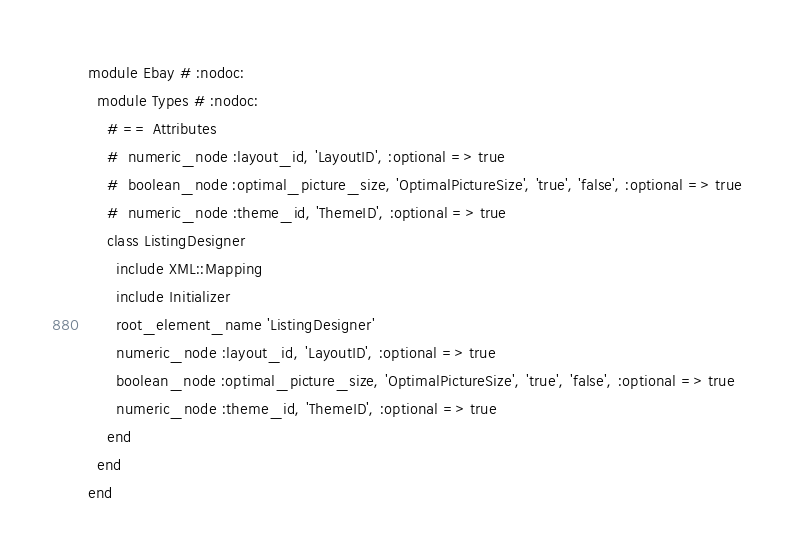<code> <loc_0><loc_0><loc_500><loc_500><_Ruby_>
module Ebay # :nodoc:
  module Types # :nodoc:
    # == Attributes
    #  numeric_node :layout_id, 'LayoutID', :optional => true
    #  boolean_node :optimal_picture_size, 'OptimalPictureSize', 'true', 'false', :optional => true
    #  numeric_node :theme_id, 'ThemeID', :optional => true
    class ListingDesigner
      include XML::Mapping
      include Initializer
      root_element_name 'ListingDesigner'
      numeric_node :layout_id, 'LayoutID', :optional => true
      boolean_node :optimal_picture_size, 'OptimalPictureSize', 'true', 'false', :optional => true
      numeric_node :theme_id, 'ThemeID', :optional => true
    end
  end
end


</code> 